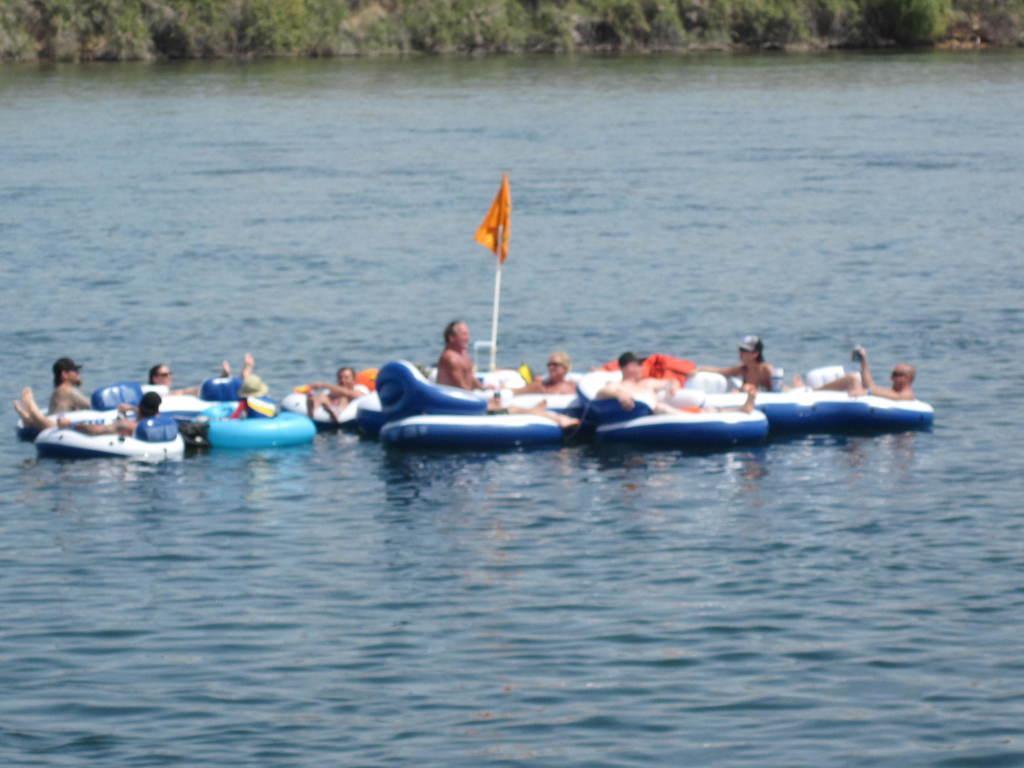Could you give a brief overview of what you see in this image? In the middle of the image there is water. Above the water few people are sitting on boats. At the top of the image there are some trees. 